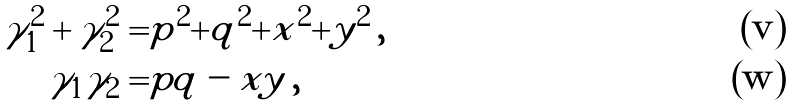<formula> <loc_0><loc_0><loc_500><loc_500>\gamma _ { 1 } ^ { 2 } + \gamma _ { 2 } ^ { 2 } & = | p | ^ { 2 } + | q | ^ { 2 } + | x | ^ { 2 } + | y | ^ { 2 } \, , \\ \gamma _ { 1 } \gamma _ { 2 } & = | p q - x y | \, ,</formula> 